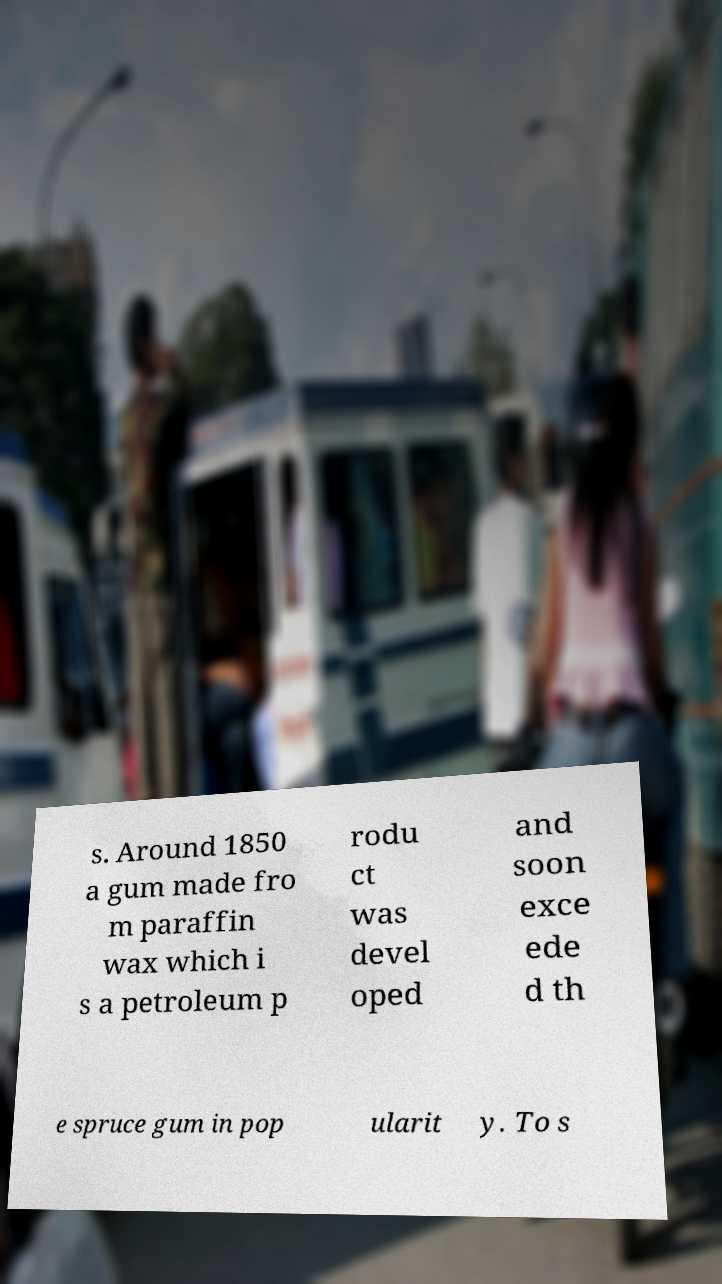Can you read and provide the text displayed in the image?This photo seems to have some interesting text. Can you extract and type it out for me? s. Around 1850 a gum made fro m paraffin wax which i s a petroleum p rodu ct was devel oped and soon exce ede d th e spruce gum in pop ularit y. To s 